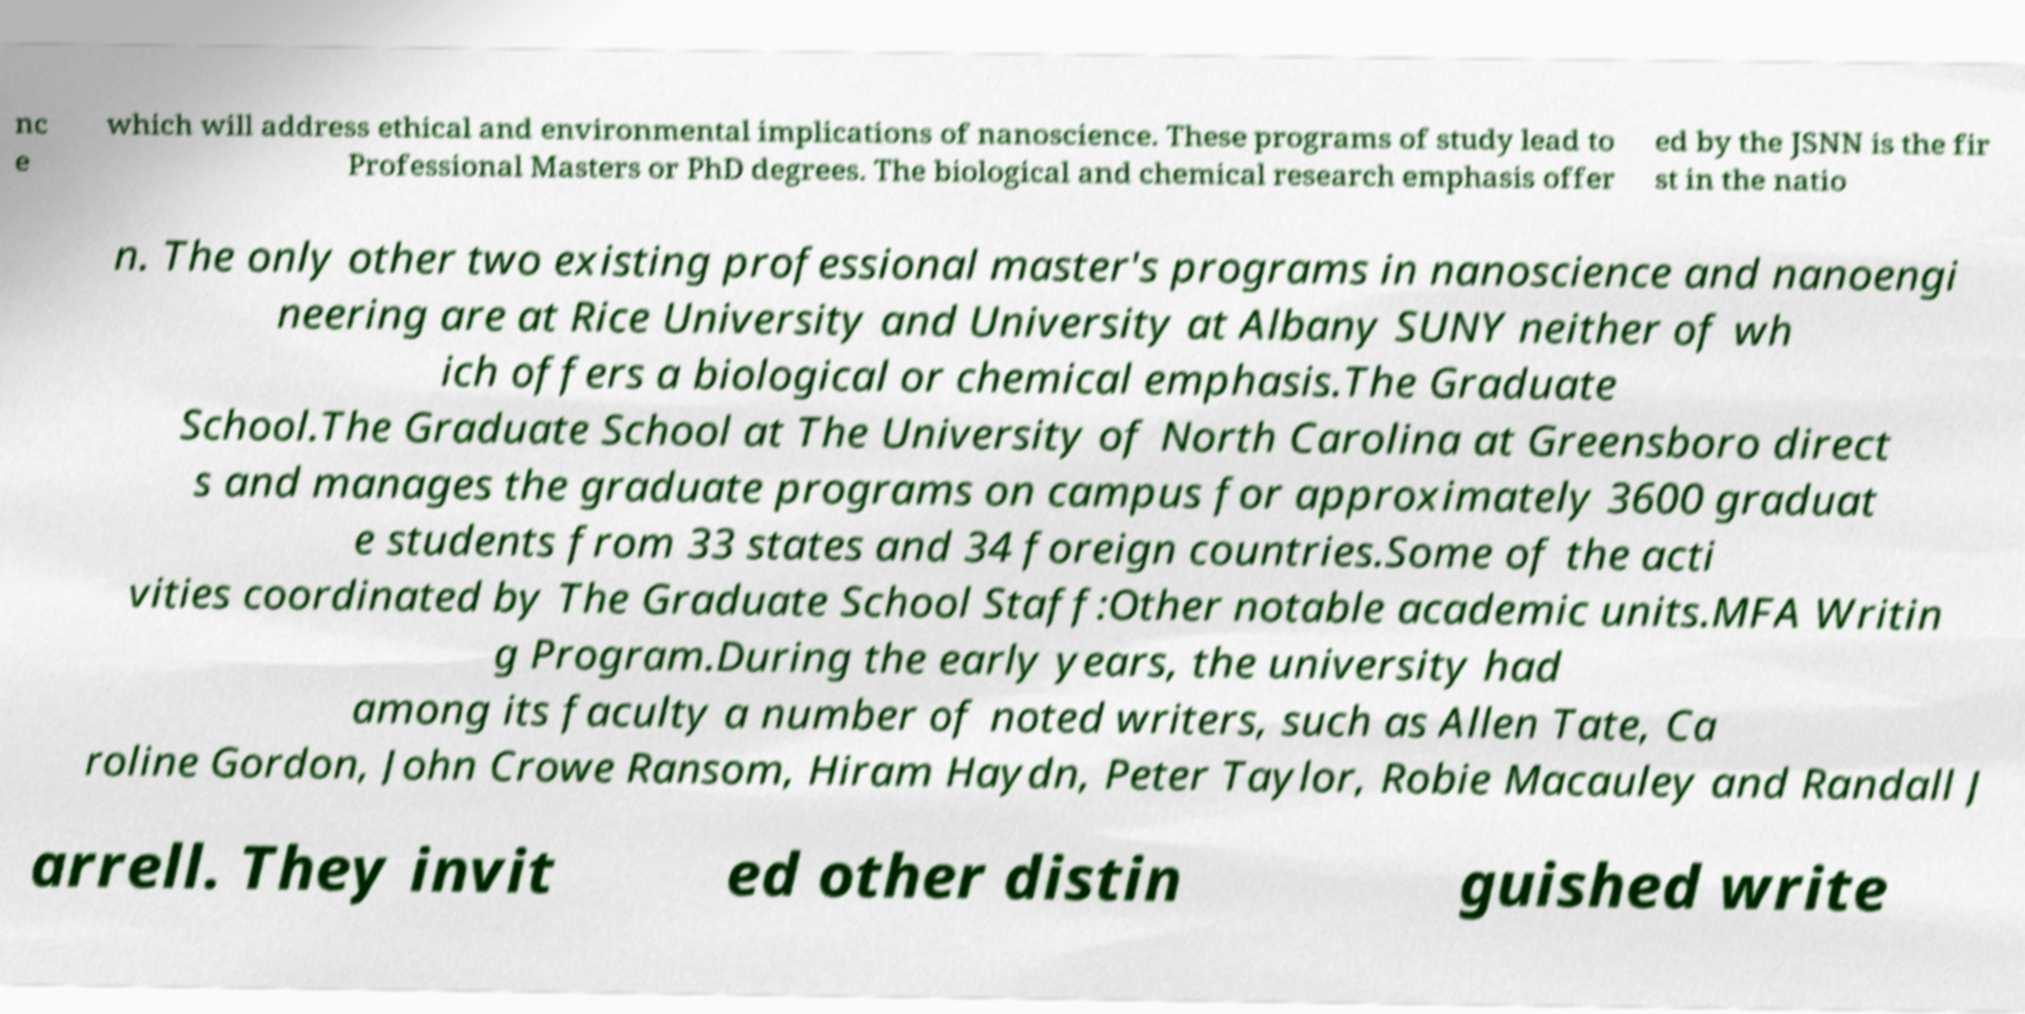Please identify and transcribe the text found in this image. nc e which will address ethical and environmental implications of nanoscience. These programs of study lead to Professional Masters or PhD degrees. The biological and chemical research emphasis offer ed by the JSNN is the fir st in the natio n. The only other two existing professional master's programs in nanoscience and nanoengi neering are at Rice University and University at Albany SUNY neither of wh ich offers a biological or chemical emphasis.The Graduate School.The Graduate School at The University of North Carolina at Greensboro direct s and manages the graduate programs on campus for approximately 3600 graduat e students from 33 states and 34 foreign countries.Some of the acti vities coordinated by The Graduate School Staff:Other notable academic units.MFA Writin g Program.During the early years, the university had among its faculty a number of noted writers, such as Allen Tate, Ca roline Gordon, John Crowe Ransom, Hiram Haydn, Peter Taylor, Robie Macauley and Randall J arrell. They invit ed other distin guished write 